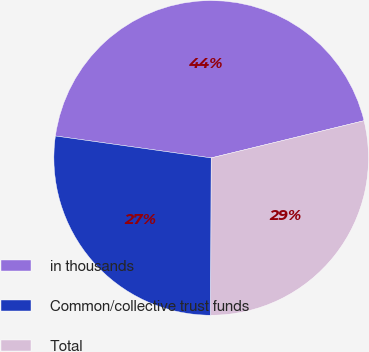<chart> <loc_0><loc_0><loc_500><loc_500><pie_chart><fcel>in thousands<fcel>Common/collective trust funds<fcel>Total<nl><fcel>43.97%<fcel>27.17%<fcel>28.85%<nl></chart> 